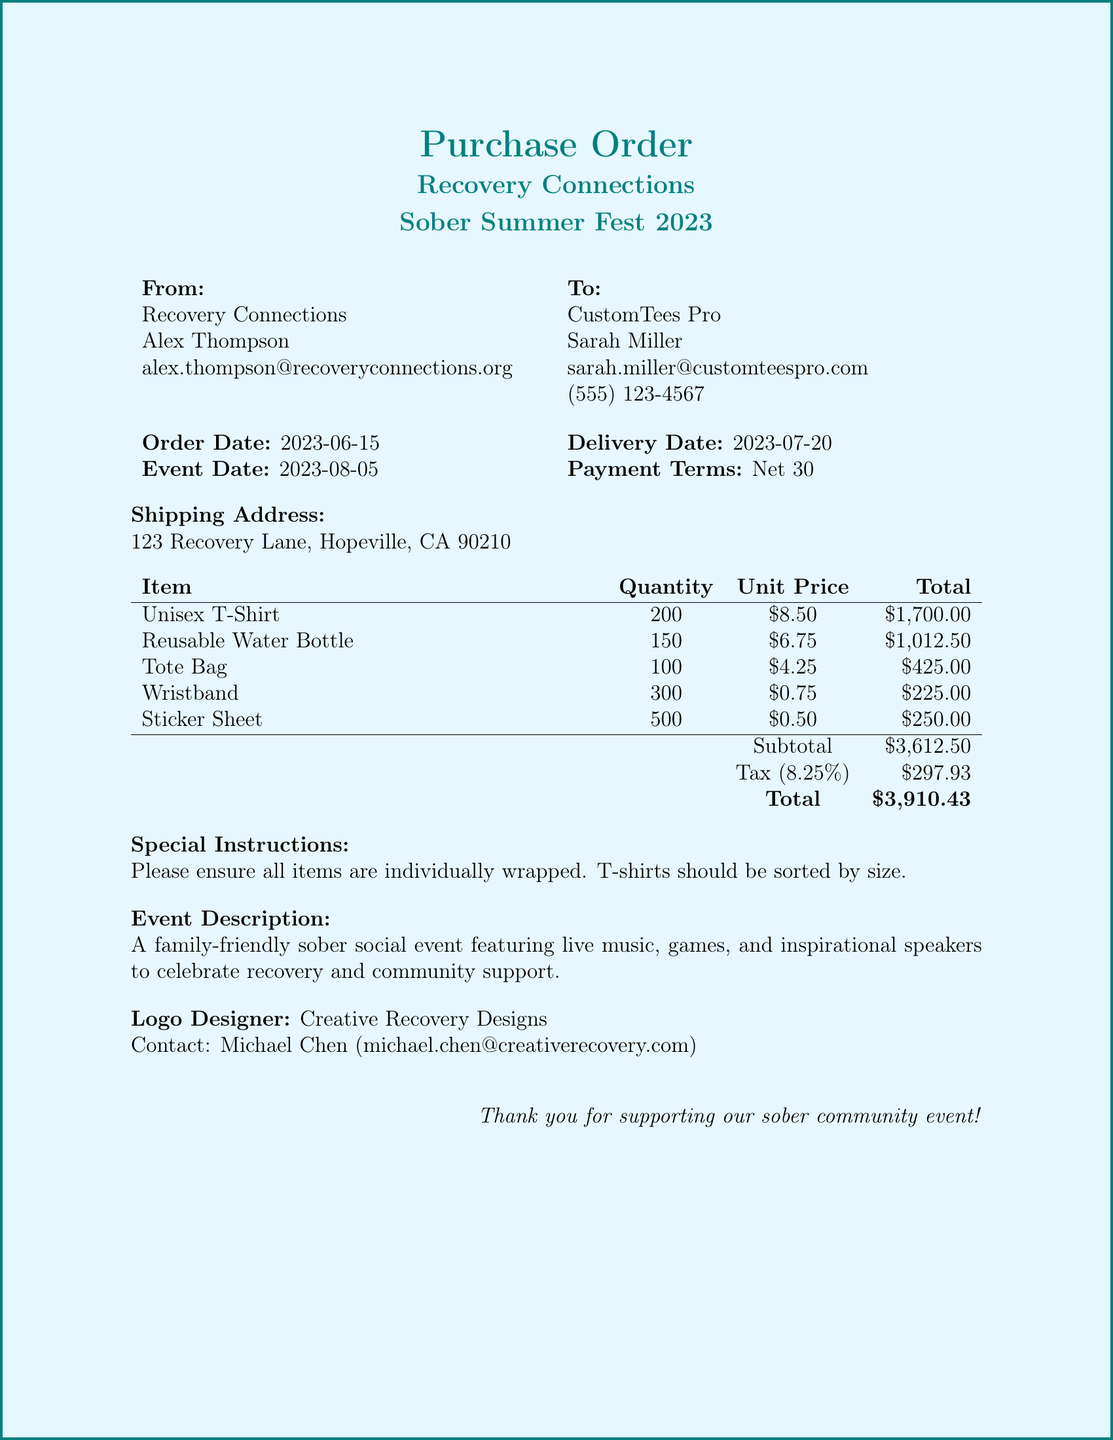what is the name of the event? The name of the event is explicitly stated in the document as "Sober Summer Fest 2023."
Answer: Sober Summer Fest 2023 who is the organizer of the event? The organizer is mentioned in the document as "Alex Thompson."
Answer: Alex Thompson what is the quantity of Unisex T-Shirts ordered? The document specifies that the quantity ordered for Unisex T-Shirts is 200.
Answer: 200 when is the delivery date for the order? The delivery date is clearly indicated in the document as "2023-07-20."
Answer: 2023-07-20 what is the total cost of the order? The total cost is presented in the document as "$3,910.43."
Answer: $3,910.43 what special instructions are provided for the order? The document includes special instructions stating items should be "individually wrapped."
Answer: individually wrapped how many different items are being ordered? The document lists five different items, which are Unisex T-Shirt, Reusable Water Bottle, Tote Bag, Wristband, and Sticker Sheet.
Answer: 5 what is the shipping method for the order? The shipping method is stated in the document as "UPS Ground."
Answer: UPS Ground who is the contact for the logo designer? The logo designer contact provided in the document is "Michael Chen."
Answer: Michael Chen 